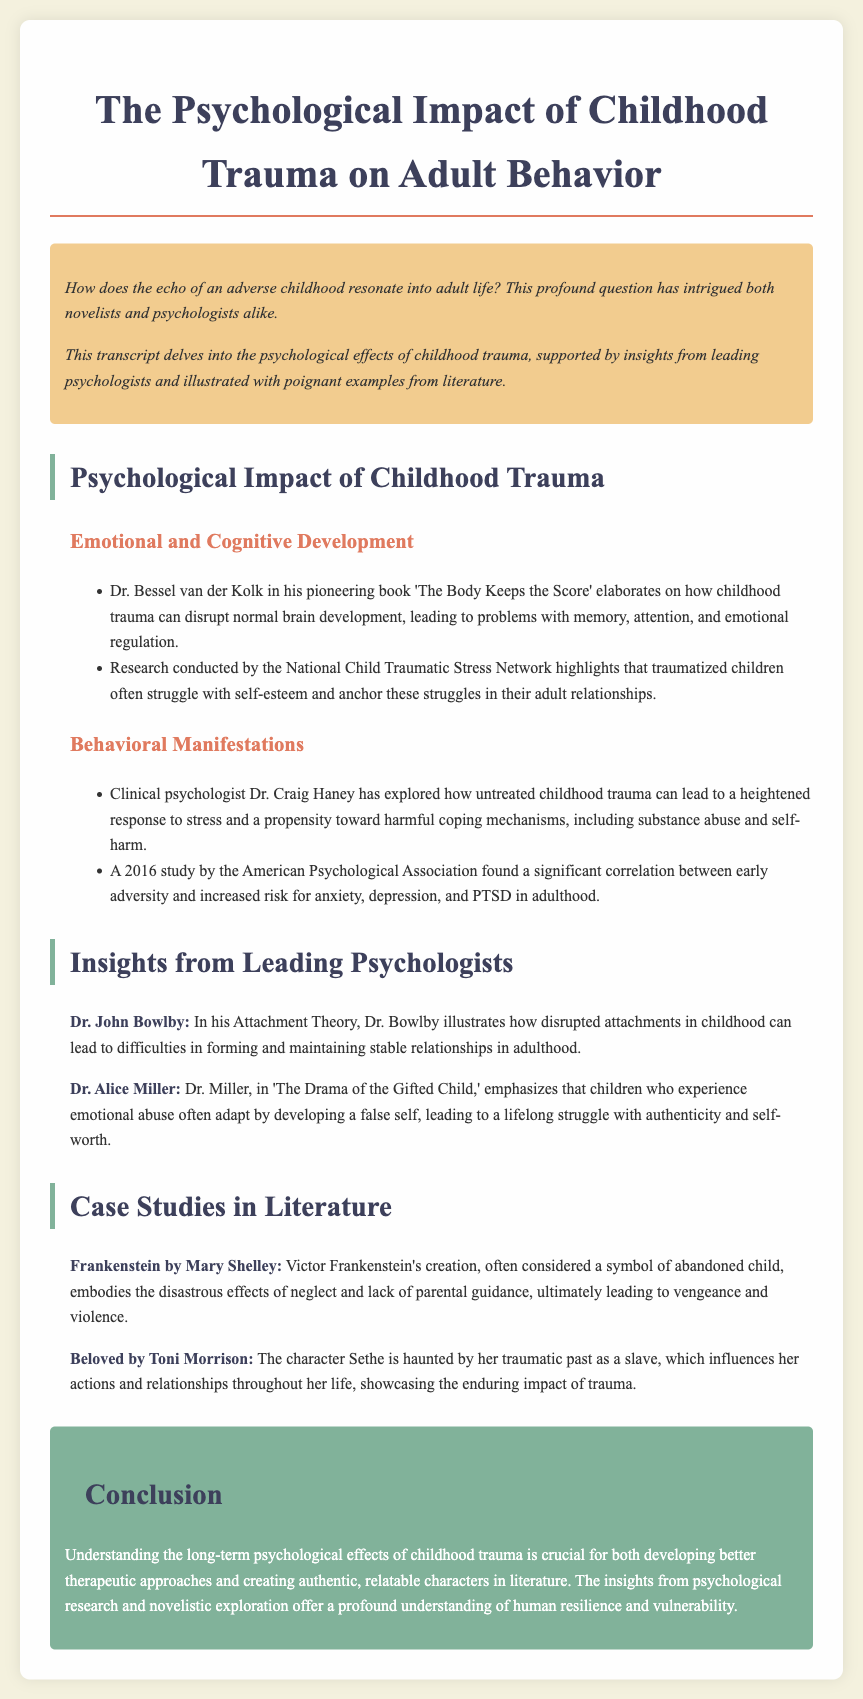What is the title of the transcript? The title is found at the top of the document, which is "The Psychological Impact of Childhood Trauma on Adult Behavior."
Answer: The Psychological Impact of Childhood Trauma on Adult Behavior Who authored 'The Body Keeps the Score'? This information is provided in the section discussing emotional and cognitive development, where Dr. Bessel van der Kolk is mentioned.
Answer: Dr. Bessel van der Kolk What theory is Dr. John Bowlby known for? The document states that he is known for his Attachment Theory, which is mentioned under insights from leading psychologists.
Answer: Attachment Theory Which novel features the character Sethe? This character is discussed in the section on case studies in literature, and the relevant novel is mentioned alongside it.
Answer: Beloved What is a key effect of childhood trauma mentioned in the document? The document lists multiple psychological impacts, with a focus on issues such as problems with memory, attention, and emotional regulation.
Answer: Problems with memory, attention, and emotional regulation According to the document, what can untreated childhood trauma lead to? The document lists heightened response to stress and a propensity toward harmful coping mechanisms as outcomes of untreated trauma.
Answer: Heightened response to stress and harmful coping mechanisms What does Dr. Alice Miller emphasize in her book? The document highlights Dr. Miller's emphasis on the development of a false self due to emotional abuse experienced in childhood.
Answer: Development of a false self What is the primary theme of *Frankenstein* as discussed in the transcript? The document describes the theme as relating to the disastrous effects of neglect and lack of parental guidance.
Answer: Disastrous effects of neglect and lack of parental guidance 